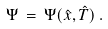Convert formula to latex. <formula><loc_0><loc_0><loc_500><loc_500>\Psi \, = \, \Psi ( \hat { x } , \hat { T } ) \, .</formula> 